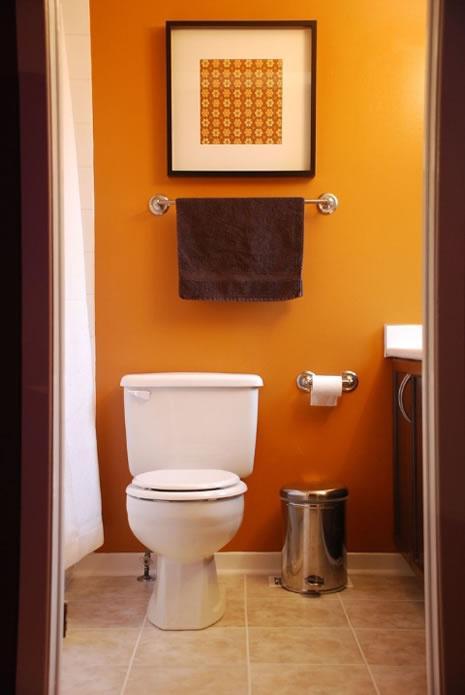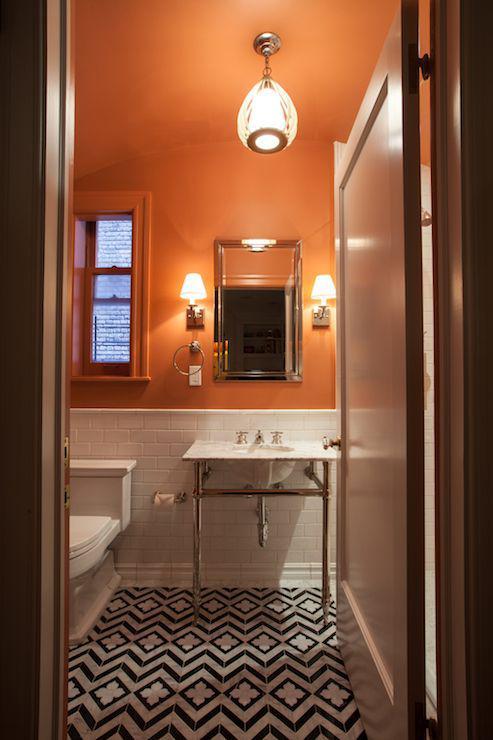The first image is the image on the left, the second image is the image on the right. Given the left and right images, does the statement "There are two sinks on top of cabinets." hold true? Answer yes or no. No. The first image is the image on the left, the second image is the image on the right. Evaluate the accuracy of this statement regarding the images: "Mirrors hang over a sink in each of the images.". Is it true? Answer yes or no. No. 